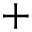Convert formula to latex. <formula><loc_0><loc_0><loc_500><loc_500>+</formula> 